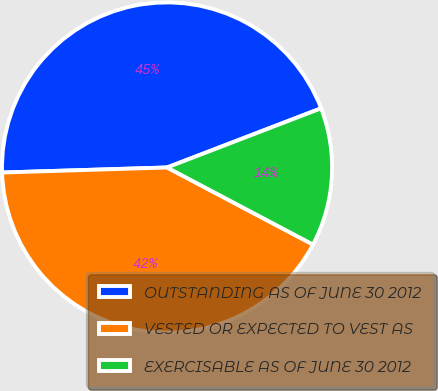Convert chart to OTSL. <chart><loc_0><loc_0><loc_500><loc_500><pie_chart><fcel>OUTSTANDING AS OF JUNE 30 2012<fcel>VESTED OR EXPECTED TO VEST AS<fcel>EXERCISABLE AS OF JUNE 30 2012<nl><fcel>44.65%<fcel>41.78%<fcel>13.57%<nl></chart> 